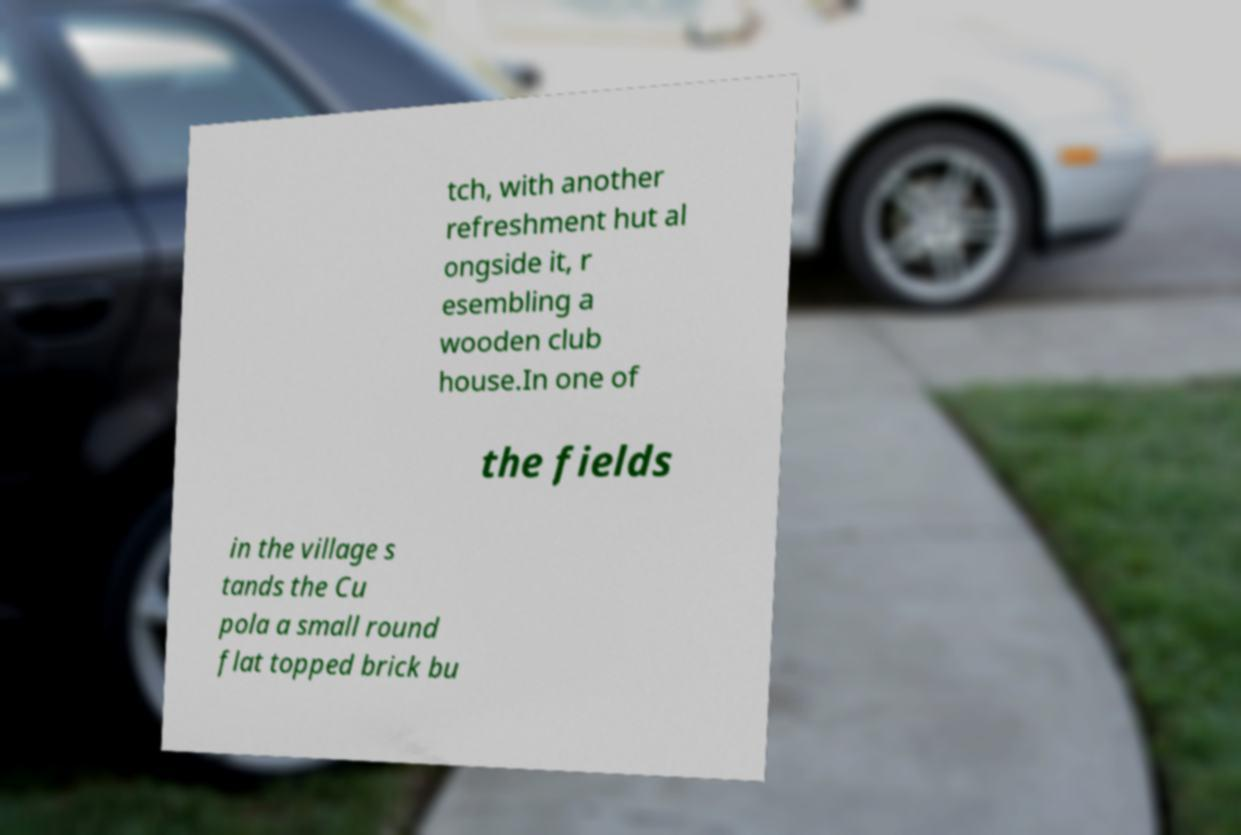For documentation purposes, I need the text within this image transcribed. Could you provide that? tch, with another refreshment hut al ongside it, r esembling a wooden club house.In one of the fields in the village s tands the Cu pola a small round flat topped brick bu 